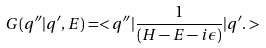<formula> <loc_0><loc_0><loc_500><loc_500>G ( q ^ { \prime \prime } | q ^ { \prime } , E ) = < q ^ { \prime \prime } | \frac { 1 } { ( H - E - i \epsilon ) } | q ^ { \prime } . ></formula> 